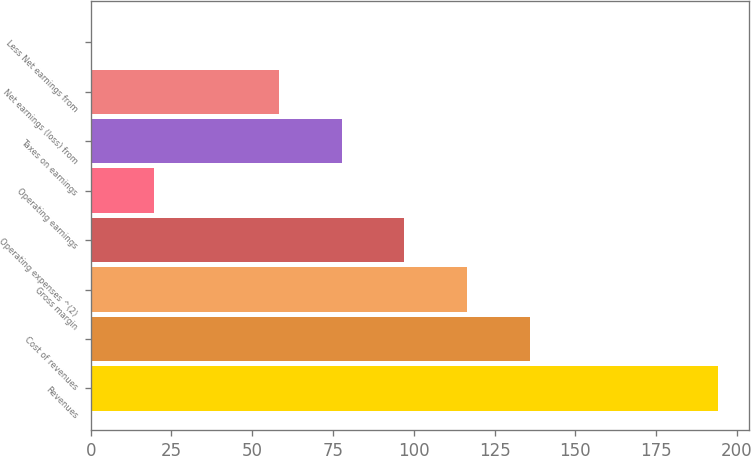<chart> <loc_0><loc_0><loc_500><loc_500><bar_chart><fcel>Revenues<fcel>Cost of revenues<fcel>Gross margin<fcel>Operating expenses ^(2)<fcel>Operating earnings<fcel>Taxes on earnings<fcel>Net earnings (loss) from<fcel>Less Net earnings from<nl><fcel>194<fcel>135.83<fcel>116.44<fcel>97.05<fcel>19.49<fcel>77.66<fcel>58.27<fcel>0.1<nl></chart> 